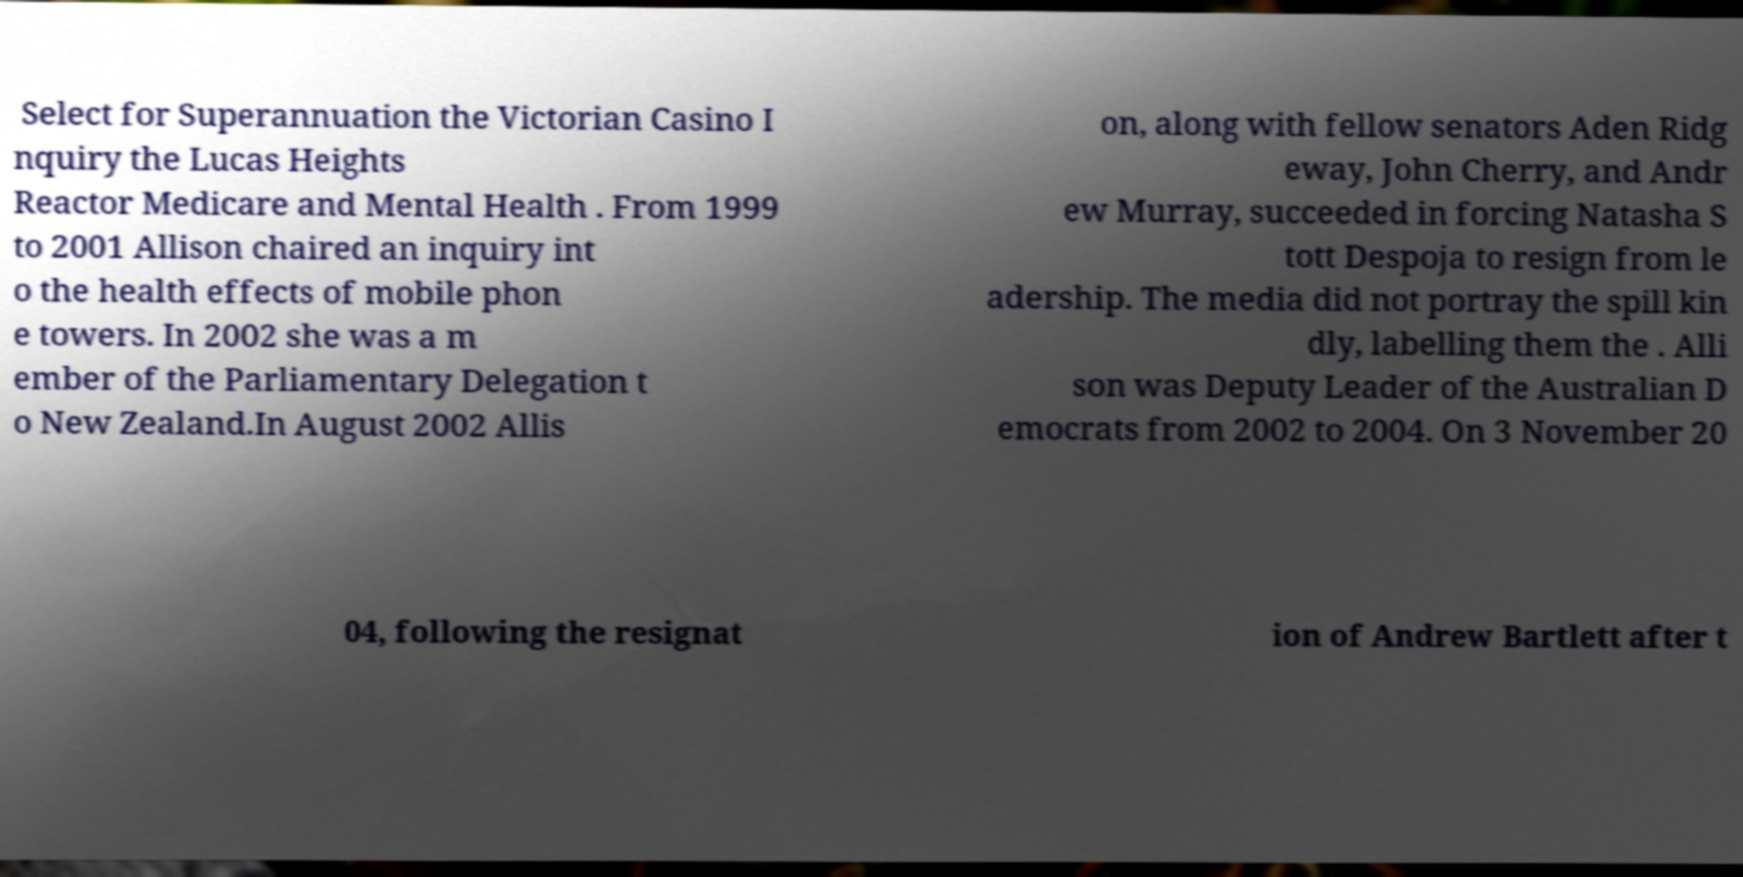Please read and relay the text visible in this image. What does it say? Select for Superannuation the Victorian Casino I nquiry the Lucas Heights Reactor Medicare and Mental Health . From 1999 to 2001 Allison chaired an inquiry int o the health effects of mobile phon e towers. In 2002 she was a m ember of the Parliamentary Delegation t o New Zealand.In August 2002 Allis on, along with fellow senators Aden Ridg eway, John Cherry, and Andr ew Murray, succeeded in forcing Natasha S tott Despoja to resign from le adership. The media did not portray the spill kin dly, labelling them the . Alli son was Deputy Leader of the Australian D emocrats from 2002 to 2004. On 3 November 20 04, following the resignat ion of Andrew Bartlett after t 